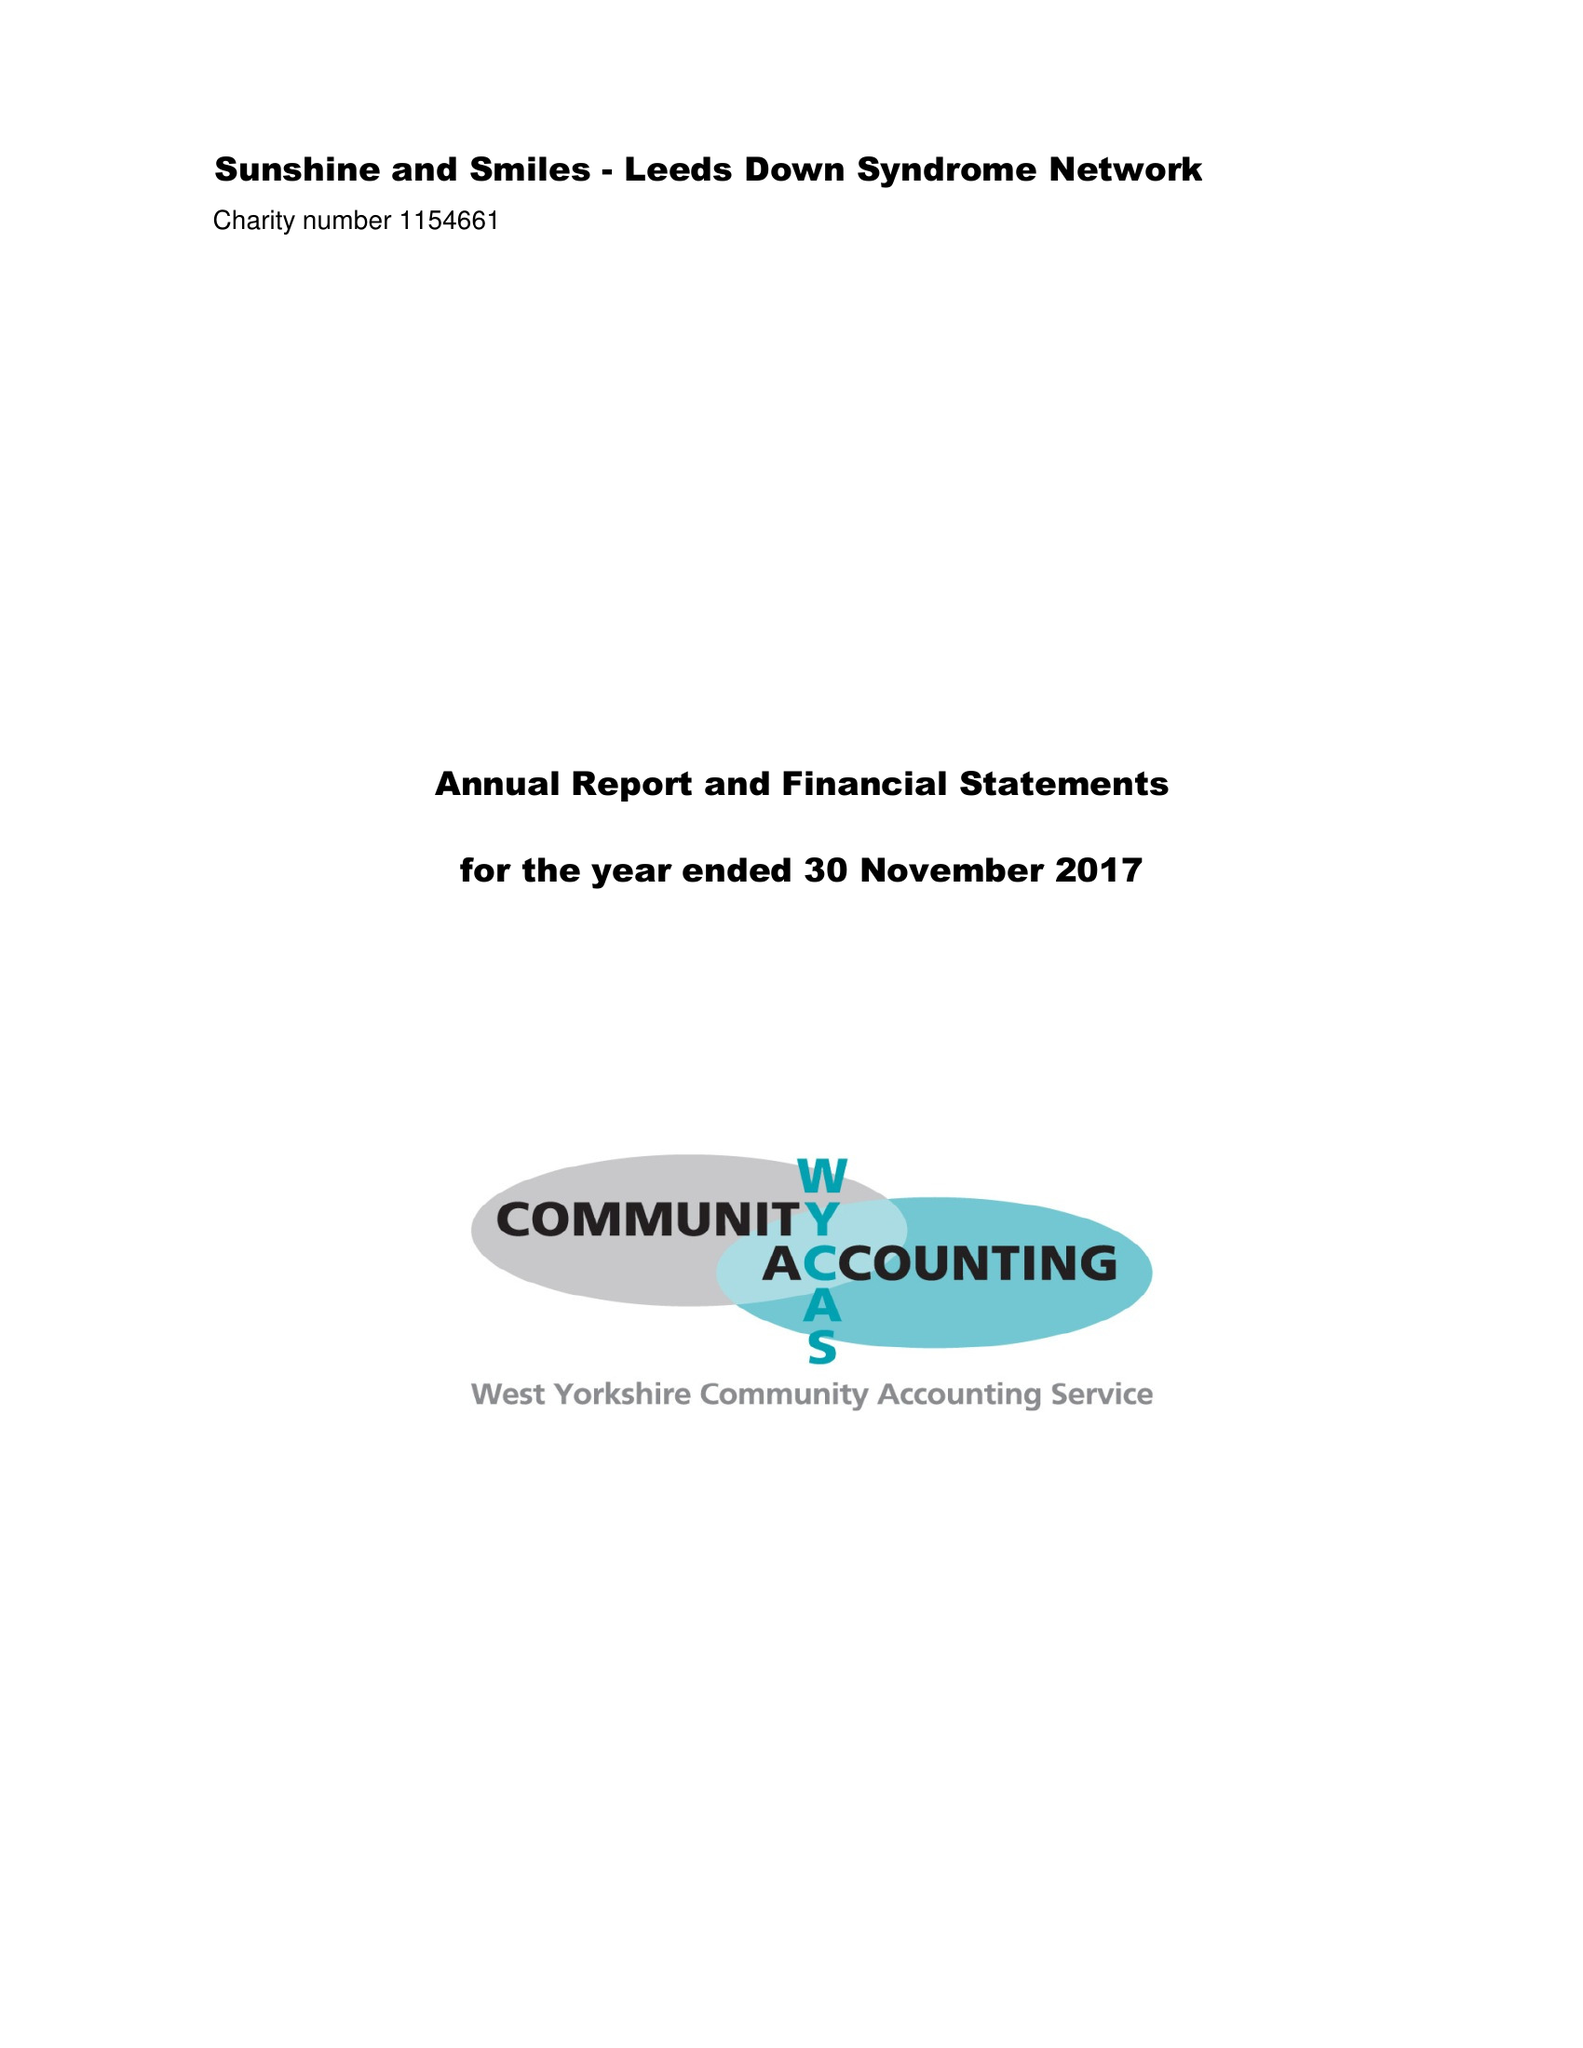What is the value for the charity_name?
Answer the question using a single word or phrase. Sunshine and Smiles - Leeds Down Syndrome Network 